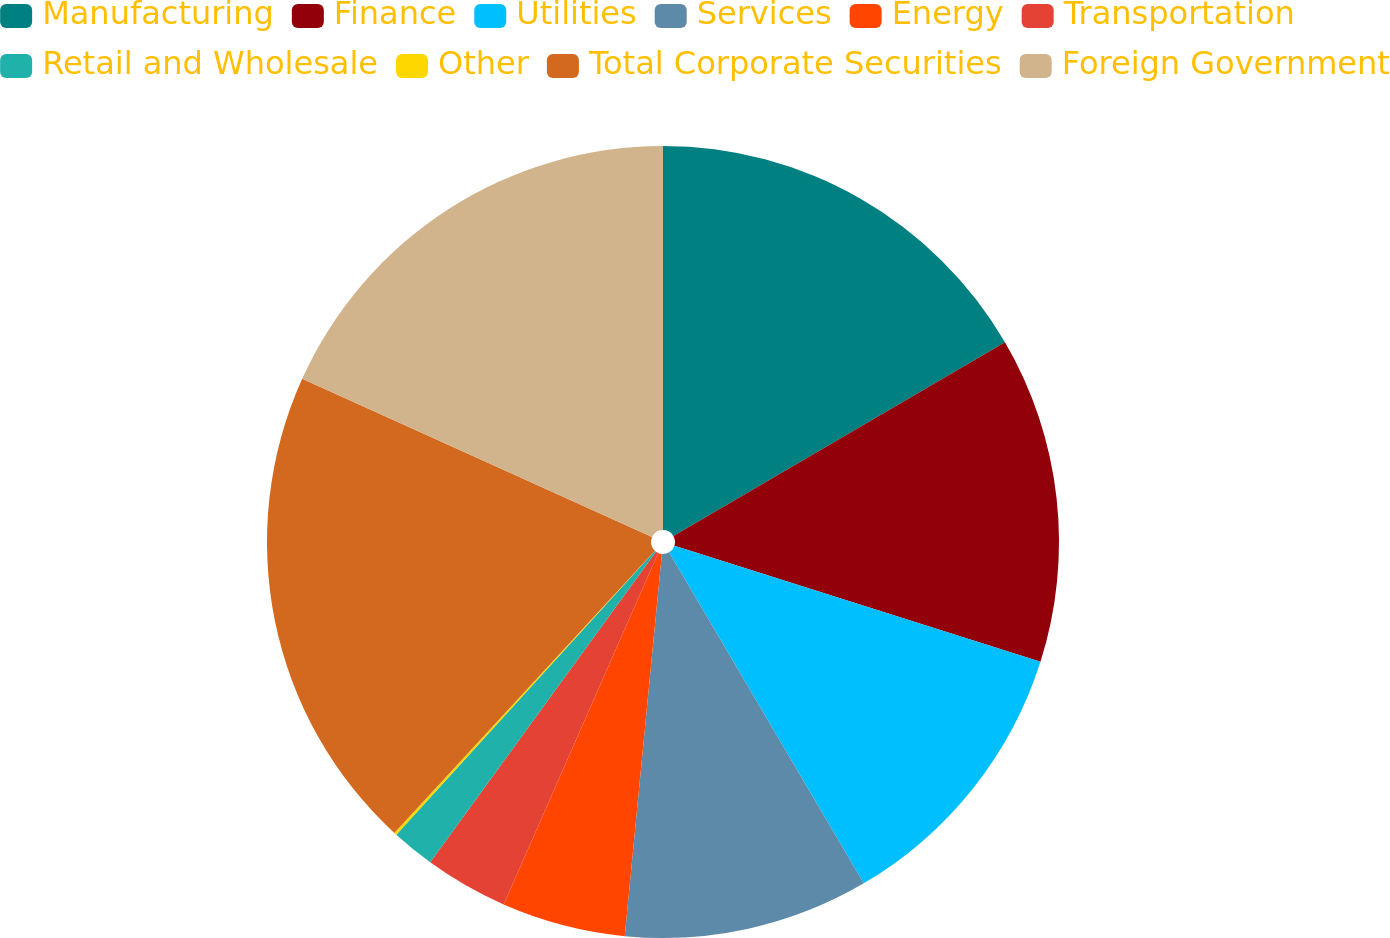<chart> <loc_0><loc_0><loc_500><loc_500><pie_chart><fcel>Manufacturing<fcel>Finance<fcel>Utilities<fcel>Services<fcel>Energy<fcel>Transportation<fcel>Retail and Wholesale<fcel>Other<fcel>Total Corporate Securities<fcel>Foreign Government<nl><fcel>16.59%<fcel>13.3%<fcel>11.65%<fcel>10.0%<fcel>5.05%<fcel>3.41%<fcel>1.76%<fcel>0.11%<fcel>19.89%<fcel>18.24%<nl></chart> 